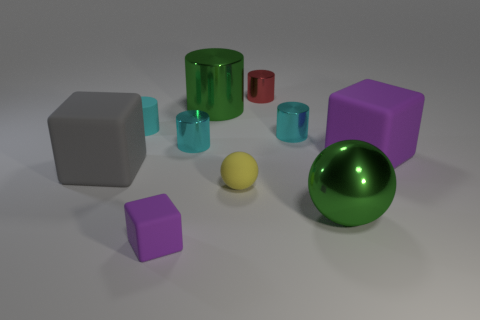Subtract all brown balls. How many cyan cylinders are left? 3 Subtract all rubber cylinders. How many cylinders are left? 4 Subtract all gray cylinders. Subtract all yellow spheres. How many cylinders are left? 5 Subtract all cubes. How many objects are left? 7 Subtract 1 purple blocks. How many objects are left? 9 Subtract all big brown objects. Subtract all big purple matte blocks. How many objects are left? 9 Add 1 large metallic spheres. How many large metallic spheres are left? 2 Add 7 gray blocks. How many gray blocks exist? 8 